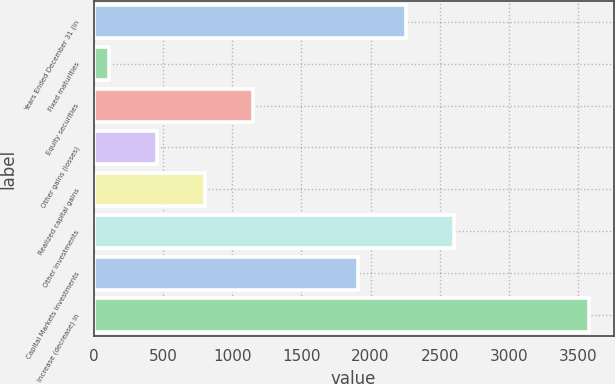<chart> <loc_0><loc_0><loc_500><loc_500><bar_chart><fcel>Years Ended December 31 (in<fcel>Fixed maturities<fcel>Equity securities<fcel>Other gains (losses)<fcel>Realized capital gains<fcel>Other investments<fcel>Capital Markets investments<fcel>Increase (decrease) in<nl><fcel>2255.9<fcel>108<fcel>1148.7<fcel>454.9<fcel>801.8<fcel>2602.8<fcel>1909<fcel>3577<nl></chart> 